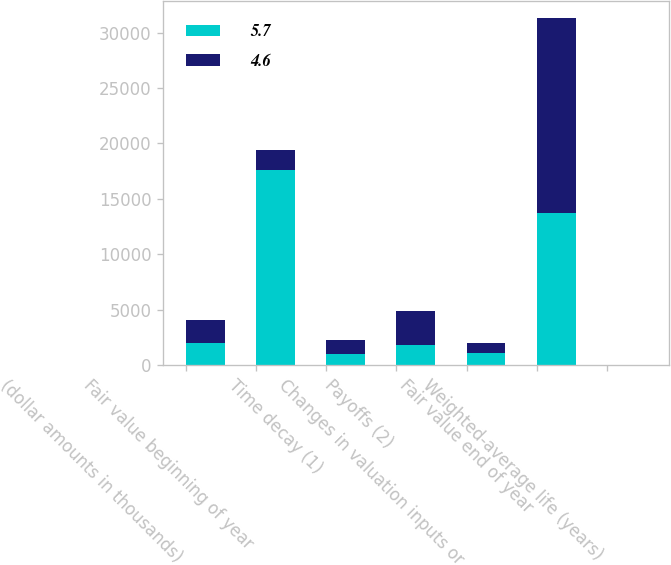<chart> <loc_0><loc_0><loc_500><loc_500><stacked_bar_chart><ecel><fcel>(dollar amounts in thousands)<fcel>Fair value beginning of year<fcel>Time decay (1)<fcel>Payoffs (2)<fcel>Changes in valuation inputs or<fcel>Fair value end of year<fcel>Weighted-average life (years)<nl><fcel>5.7<fcel>2016<fcel>17585<fcel>950<fcel>1827<fcel>1061<fcel>13747<fcel>5.7<nl><fcel>4.6<fcel>2015<fcel>1827<fcel>1295<fcel>3031<fcel>875<fcel>17585<fcel>4.6<nl></chart> 